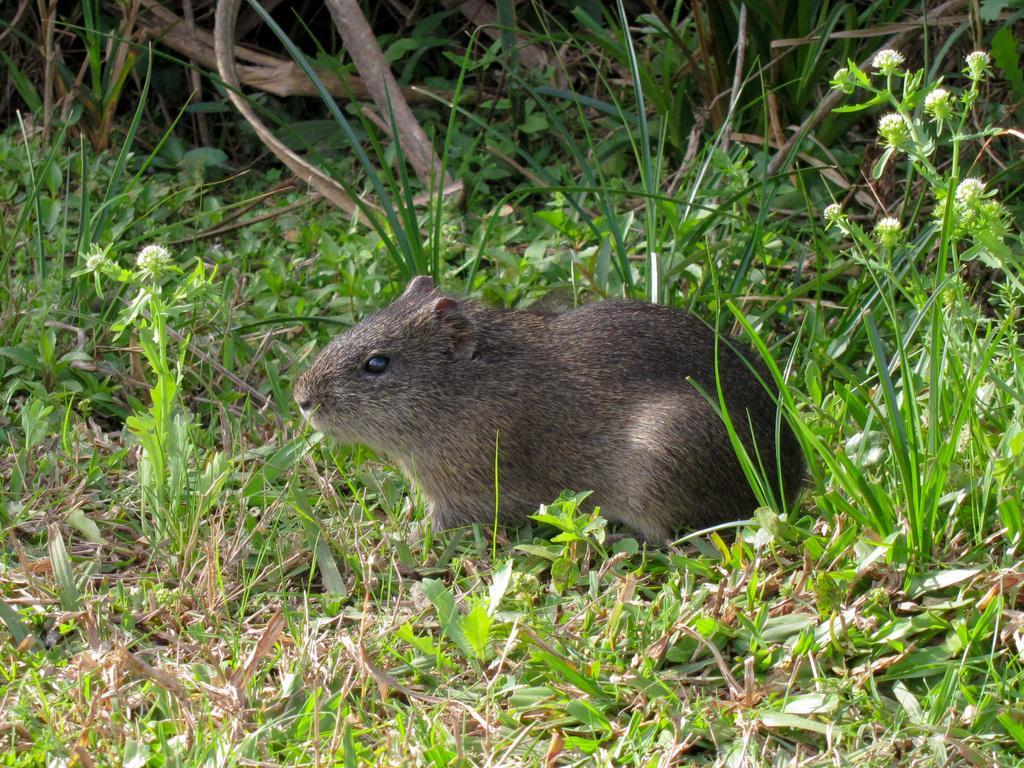Please provide a concise description of this image. In this image we can see a mammal and we can see some plants and grass on the ground. 